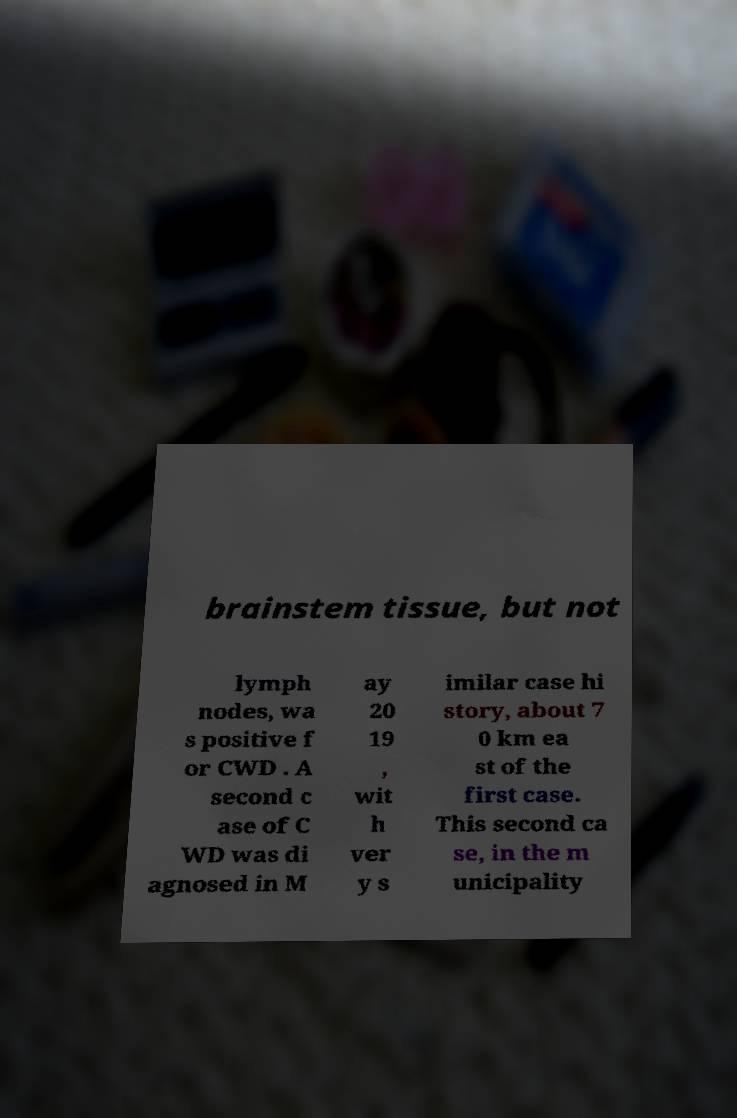I need the written content from this picture converted into text. Can you do that? brainstem tissue, but not lymph nodes, wa s positive f or CWD . A second c ase of C WD was di agnosed in M ay 20 19 , wit h ver y s imilar case hi story, about 7 0 km ea st of the first case. This second ca se, in the m unicipality 